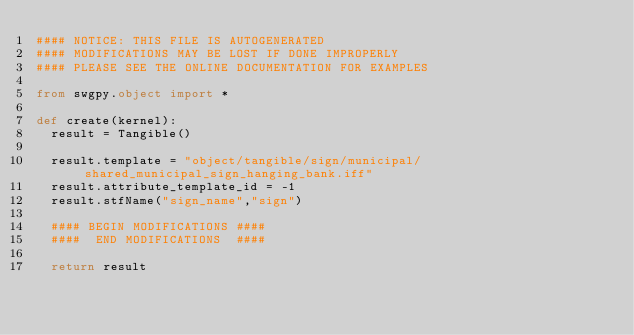Convert code to text. <code><loc_0><loc_0><loc_500><loc_500><_Python_>#### NOTICE: THIS FILE IS AUTOGENERATED
#### MODIFICATIONS MAY BE LOST IF DONE IMPROPERLY
#### PLEASE SEE THE ONLINE DOCUMENTATION FOR EXAMPLES

from swgpy.object import *	

def create(kernel):
	result = Tangible()

	result.template = "object/tangible/sign/municipal/shared_municipal_sign_hanging_bank.iff"
	result.attribute_template_id = -1
	result.stfName("sign_name","sign")		
	
	#### BEGIN MODIFICATIONS ####
	####  END MODIFICATIONS  ####
	
	return result</code> 